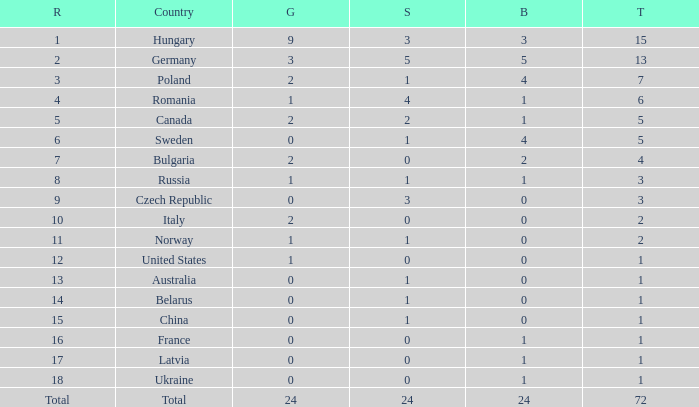How many golds have 3 as the rank, with a total greater than 7? 0.0. 